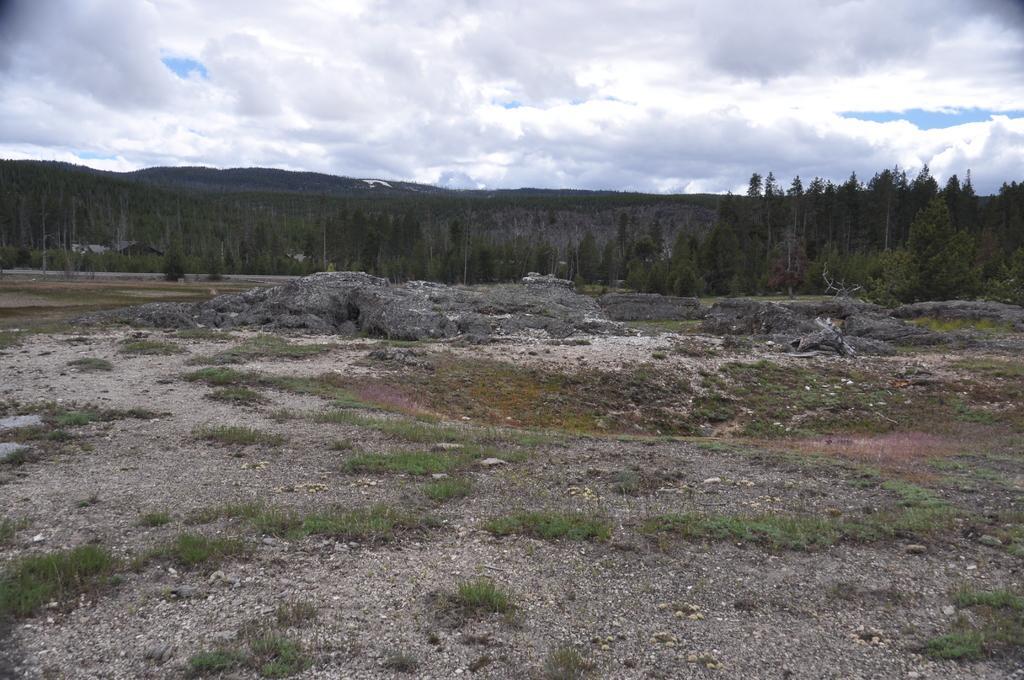Can you describe this image briefly? In this image we can see the ground, grass, rocks, trees, hills and the cloudy sky in the background. 